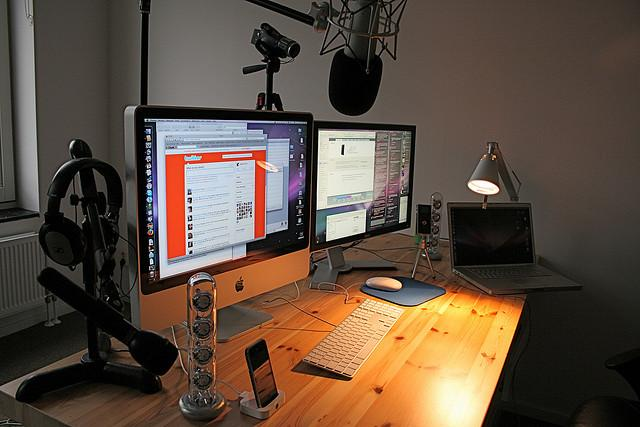What is the wooden item here? Please explain your reasoning. desk. There are computer monitors, speakers, a keyboard, a mouse, and similar items. they are on the wooden item. 